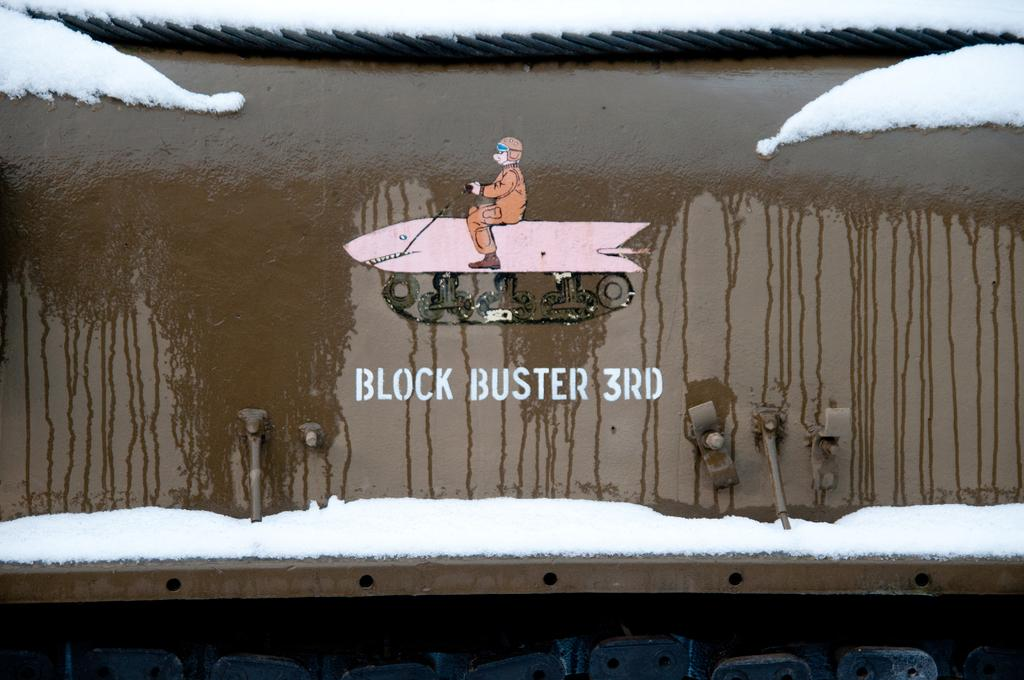<image>
Describe the image concisely. a sign on a train car reads Block Buster 3rd 